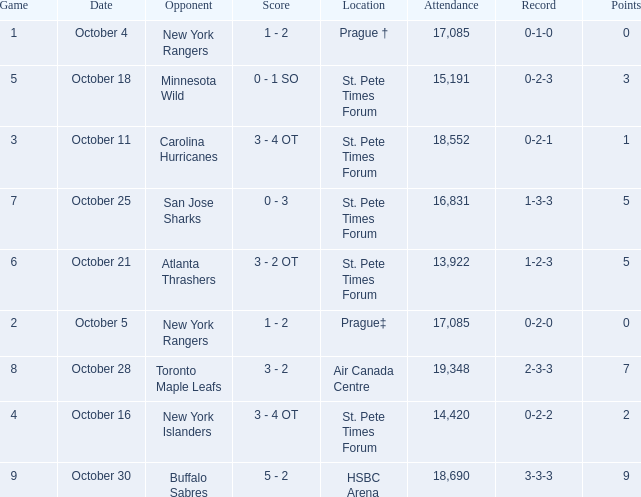What was the attendance when their record stood at 0-2-2? 14420.0. Can you give me this table as a dict? {'header': ['Game', 'Date', 'Opponent', 'Score', 'Location', 'Attendance', 'Record', 'Points'], 'rows': [['1', 'October 4', 'New York Rangers', '1 - 2', 'Prague †', '17,085', '0-1-0', '0'], ['5', 'October 18', 'Minnesota Wild', '0 - 1 SO', 'St. Pete Times Forum', '15,191', '0-2-3', '3'], ['3', 'October 11', 'Carolina Hurricanes', '3 - 4 OT', 'St. Pete Times Forum', '18,552', '0-2-1', '1'], ['7', 'October 25', 'San Jose Sharks', '0 - 3', 'St. Pete Times Forum', '16,831', '1-3-3', '5'], ['6', 'October 21', 'Atlanta Thrashers', '3 - 2 OT', 'St. Pete Times Forum', '13,922', '1-2-3', '5'], ['2', 'October 5', 'New York Rangers', '1 - 2', 'Prague‡', '17,085', '0-2-0', '0'], ['8', 'October 28', 'Toronto Maple Leafs', '3 - 2', 'Air Canada Centre', '19,348', '2-3-3', '7'], ['4', 'October 16', 'New York Islanders', '3 - 4 OT', 'St. Pete Times Forum', '14,420', '0-2-2', '2'], ['9', 'October 30', 'Buffalo Sabres', '5 - 2', 'HSBC Arena', '18,690', '3-3-3', '9']]} 